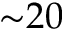Convert formula to latex. <formula><loc_0><loc_0><loc_500><loc_500>{ \sim } 2 0</formula> 